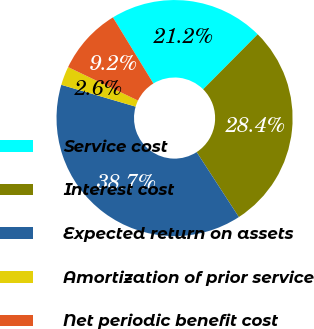Convert chart. <chart><loc_0><loc_0><loc_500><loc_500><pie_chart><fcel>Service cost<fcel>Interest cost<fcel>Expected return on assets<fcel>Amortization of prior service<fcel>Net periodic benefit cost<nl><fcel>21.18%<fcel>28.39%<fcel>38.71%<fcel>2.56%<fcel>9.15%<nl></chart> 